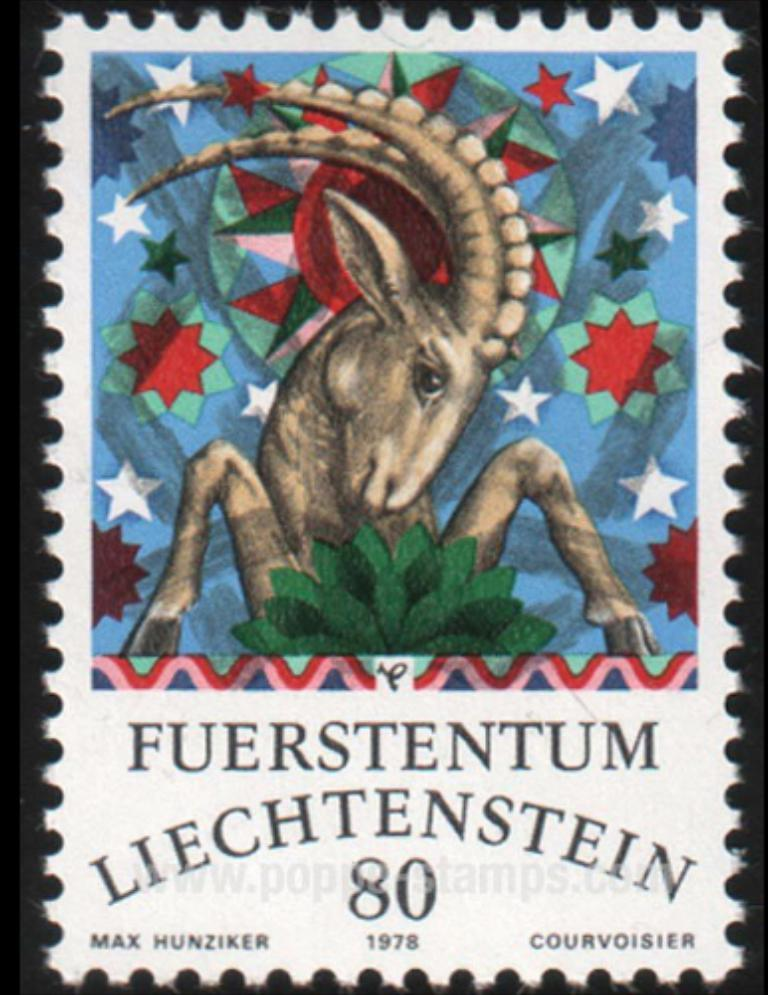What is present in the image that has text on it? There is a poster in the image with text written on it. Can you describe the text on the poster? Unfortunately, the specific content of the text cannot be determined from the image alone. What type of cabbage is being served at the meal in the image? There is no meal or cabbage present in the image; it only features a poster with text on it. 